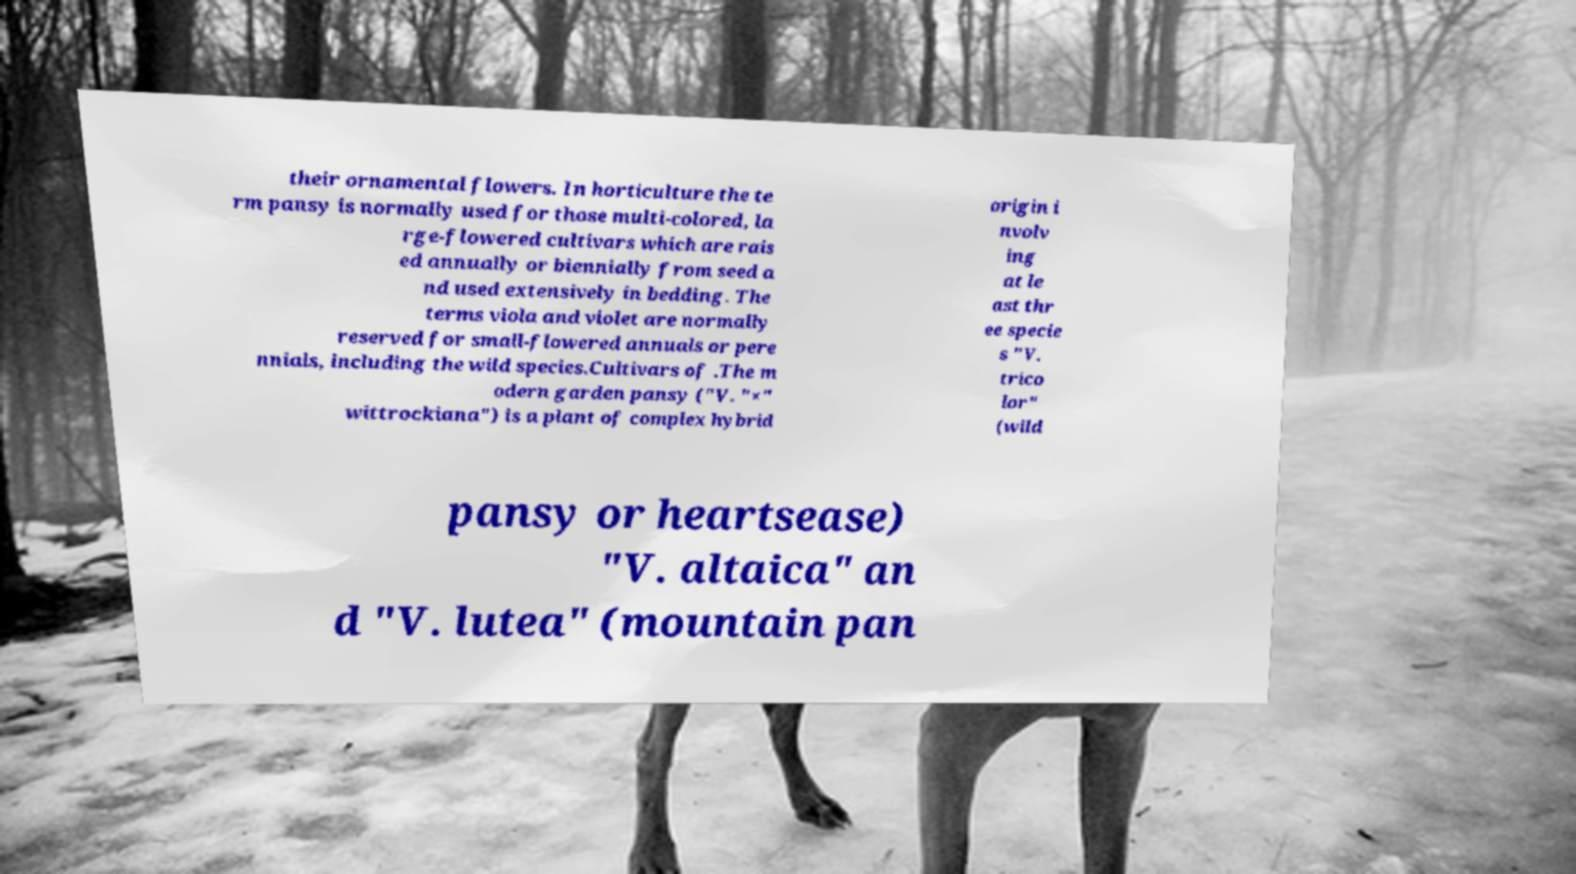Could you extract and type out the text from this image? their ornamental flowers. In horticulture the te rm pansy is normally used for those multi-colored, la rge-flowered cultivars which are rais ed annually or biennially from seed a nd used extensively in bedding. The terms viola and violet are normally reserved for small-flowered annuals or pere nnials, including the wild species.Cultivars of .The m odern garden pansy ("V. "×" wittrockiana") is a plant of complex hybrid origin i nvolv ing at le ast thr ee specie s "V. trico lor" (wild pansy or heartsease) "V. altaica" an d "V. lutea" (mountain pan 